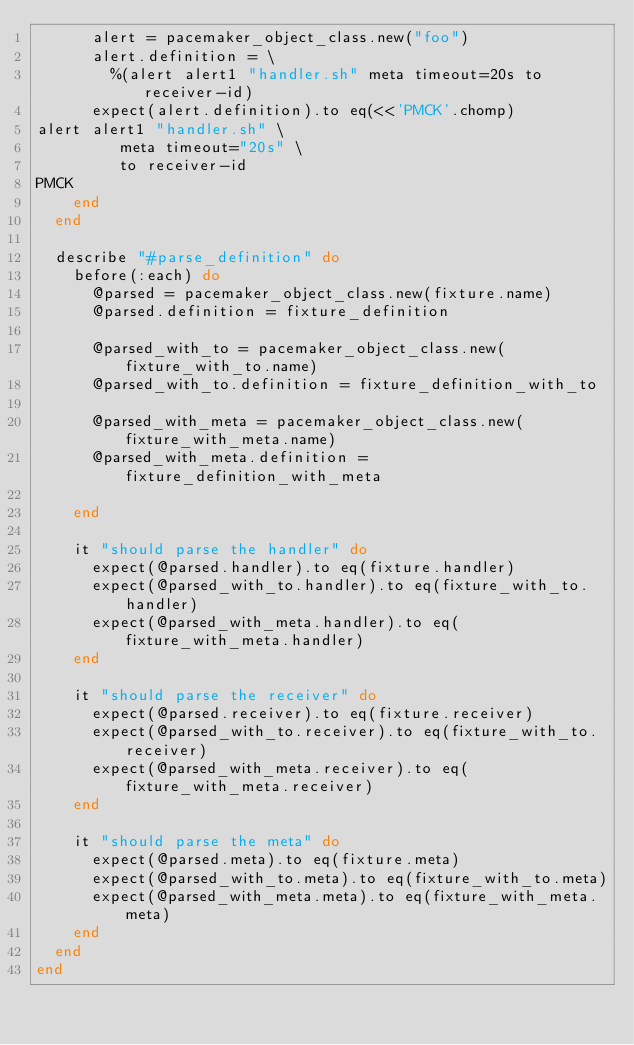<code> <loc_0><loc_0><loc_500><loc_500><_Ruby_>      alert = pacemaker_object_class.new("foo")
      alert.definition = \
        %(alert alert1 "handler.sh" meta timeout=20s to receiver-id)
      expect(alert.definition).to eq(<<'PMCK'.chomp)
alert alert1 "handler.sh" \
         meta timeout="20s" \
         to receiver-id
PMCK
    end
  end

  describe "#parse_definition" do
    before(:each) do
      @parsed = pacemaker_object_class.new(fixture.name)
      @parsed.definition = fixture_definition

      @parsed_with_to = pacemaker_object_class.new(fixture_with_to.name)
      @parsed_with_to.definition = fixture_definition_with_to

      @parsed_with_meta = pacemaker_object_class.new(fixture_with_meta.name)
      @parsed_with_meta.definition = fixture_definition_with_meta

    end

    it "should parse the handler" do
      expect(@parsed.handler).to eq(fixture.handler)
      expect(@parsed_with_to.handler).to eq(fixture_with_to.handler)
      expect(@parsed_with_meta.handler).to eq(fixture_with_meta.handler)
    end

    it "should parse the receiver" do
      expect(@parsed.receiver).to eq(fixture.receiver)
      expect(@parsed_with_to.receiver).to eq(fixture_with_to.receiver)
      expect(@parsed_with_meta.receiver).to eq(fixture_with_meta.receiver)
    end

    it "should parse the meta" do
      expect(@parsed.meta).to eq(fixture.meta)
      expect(@parsed_with_to.meta).to eq(fixture_with_to.meta)
      expect(@parsed_with_meta.meta).to eq(fixture_with_meta.meta)
    end
  end
end
</code> 